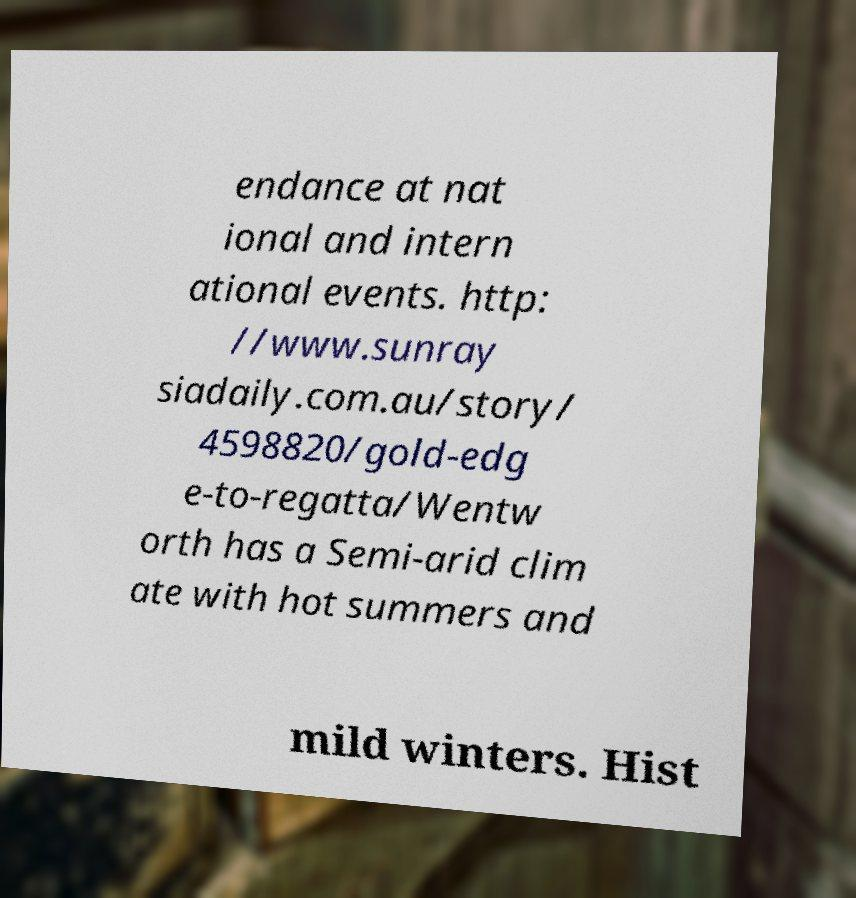Please read and relay the text visible in this image. What does it say? endance at nat ional and intern ational events. http: //www.sunray siadaily.com.au/story/ 4598820/gold-edg e-to-regatta/Wentw orth has a Semi-arid clim ate with hot summers and mild winters. Hist 